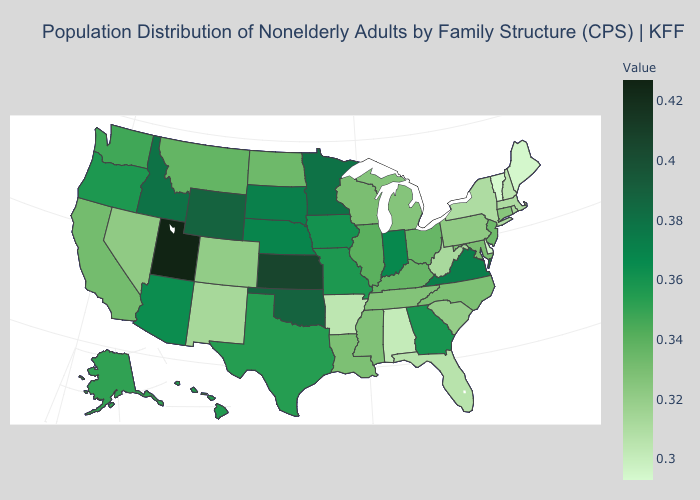Among the states that border California , which have the lowest value?
Give a very brief answer. Nevada. Which states have the highest value in the USA?
Concise answer only. Utah. Does Nevada have the highest value in the USA?
Concise answer only. No. Which states have the highest value in the USA?
Be succinct. Utah. Among the states that border Delaware , which have the highest value?
Quick response, please. New Jersey. Does Kansas have the lowest value in the MidWest?
Quick response, please. No. Which states have the lowest value in the USA?
Keep it brief. Vermont. Among the states that border New Mexico , does Texas have the highest value?
Write a very short answer. No. Does Alaska have the highest value in the USA?
Be succinct. No. 